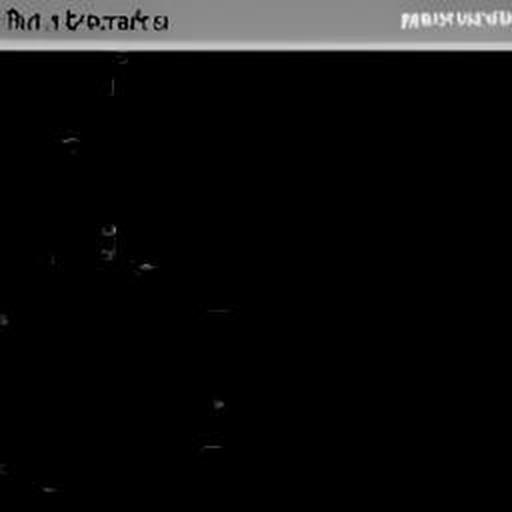How might we improve the visibility of this image? To improve visibility, one could attempt to increase the brightness and contrast using photo editing software. Additionally, if the image was indeed taken in a low light setting, using a different camera setting with a higher ISO or a longer exposure time could yield better results if the photo were to be retaken. 